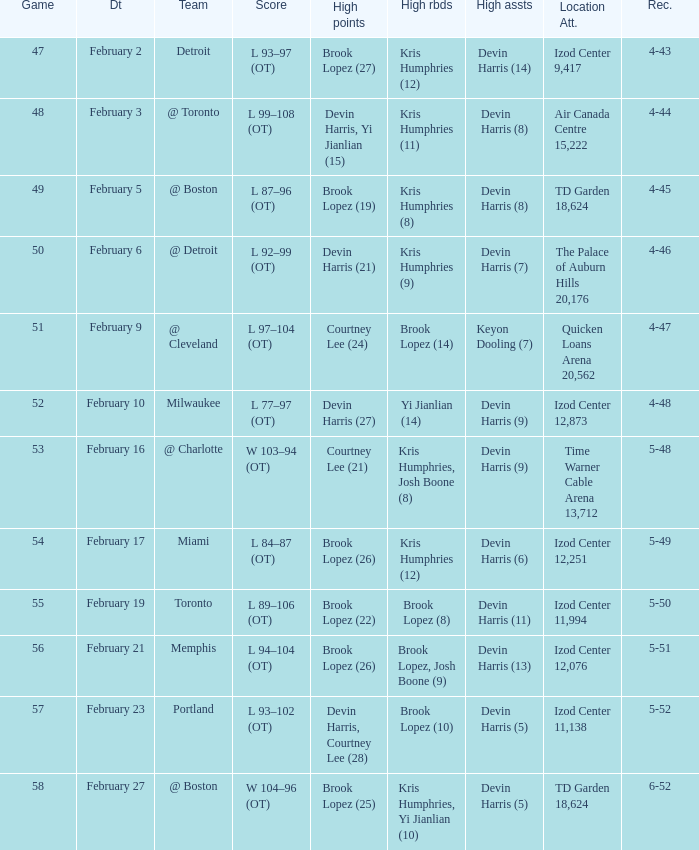What's the highest game number for a game in which Kris Humphries (8) did the high rebounds? 49.0. 